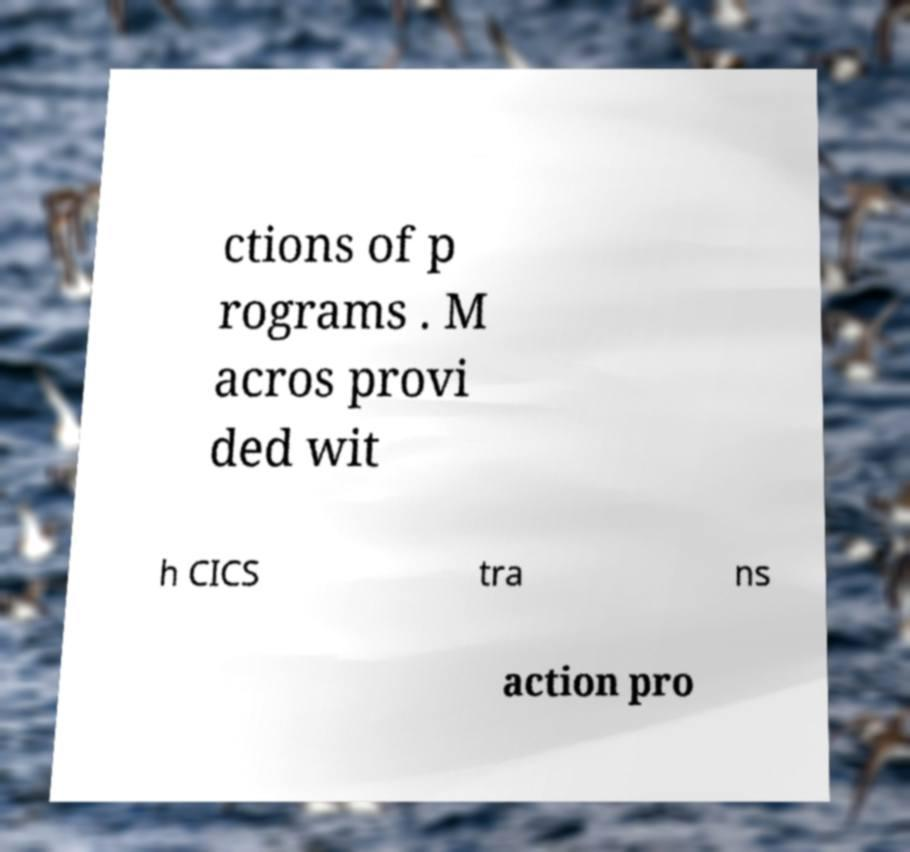Could you assist in decoding the text presented in this image and type it out clearly? ctions of p rograms . M acros provi ded wit h CICS tra ns action pro 